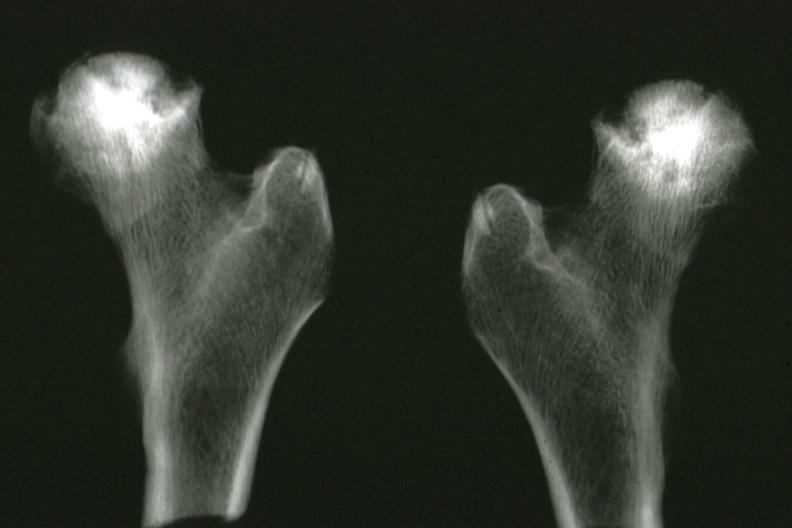what is present?
Answer the question using a single word or phrase. Joints 